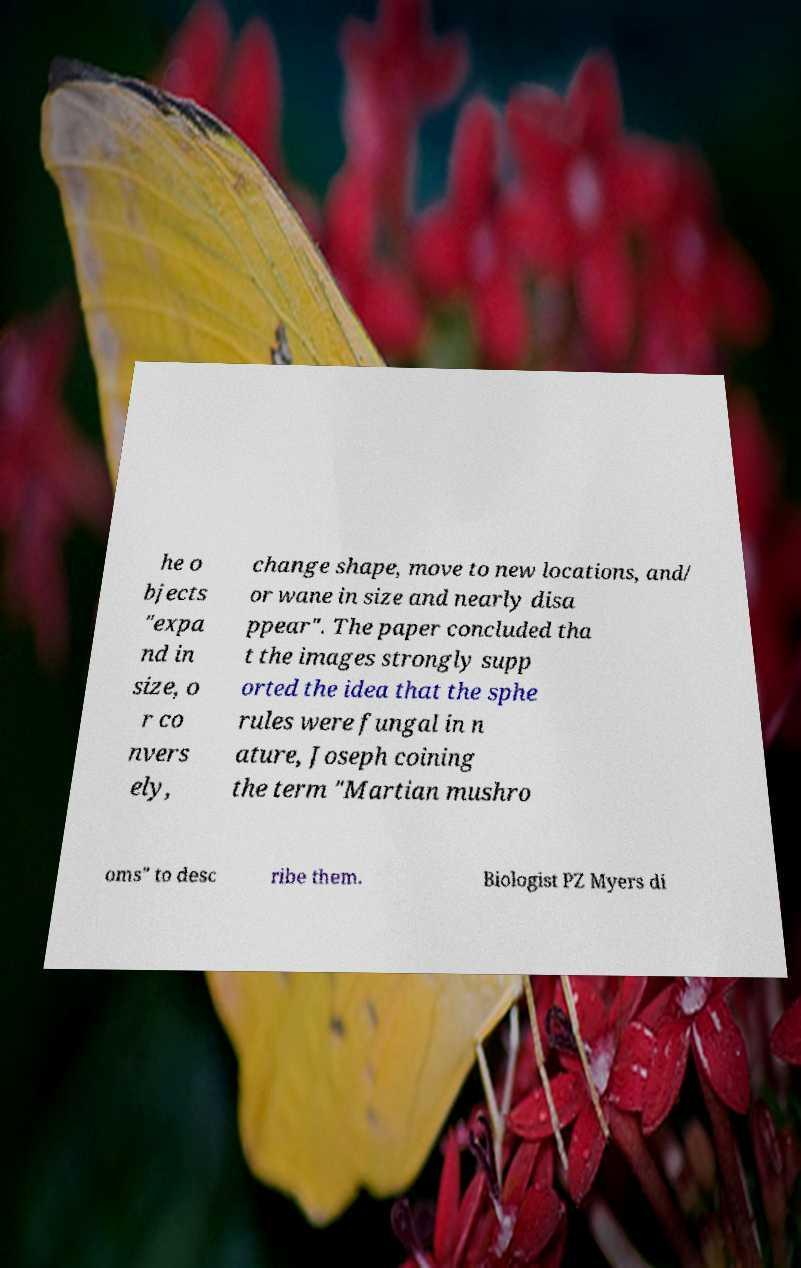Could you assist in decoding the text presented in this image and type it out clearly? he o bjects "expa nd in size, o r co nvers ely, change shape, move to new locations, and/ or wane in size and nearly disa ppear". The paper concluded tha t the images strongly supp orted the idea that the sphe rules were fungal in n ature, Joseph coining the term "Martian mushro oms" to desc ribe them. Biologist PZ Myers di 